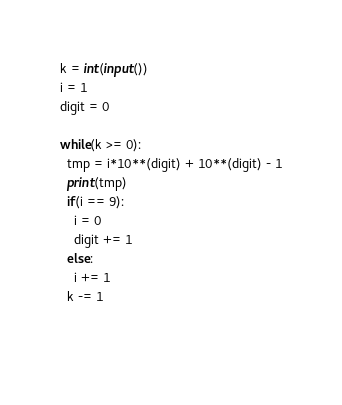Convert code to text. <code><loc_0><loc_0><loc_500><loc_500><_Python_>k = int(input())
i = 1
digit = 0

while(k >= 0):
  tmp = i*10**(digit) + 10**(digit) - 1
  print(tmp)
  if(i == 9):
    i = 0
    digit += 1
  else:
    i += 1
  k -= 1
  
  </code> 